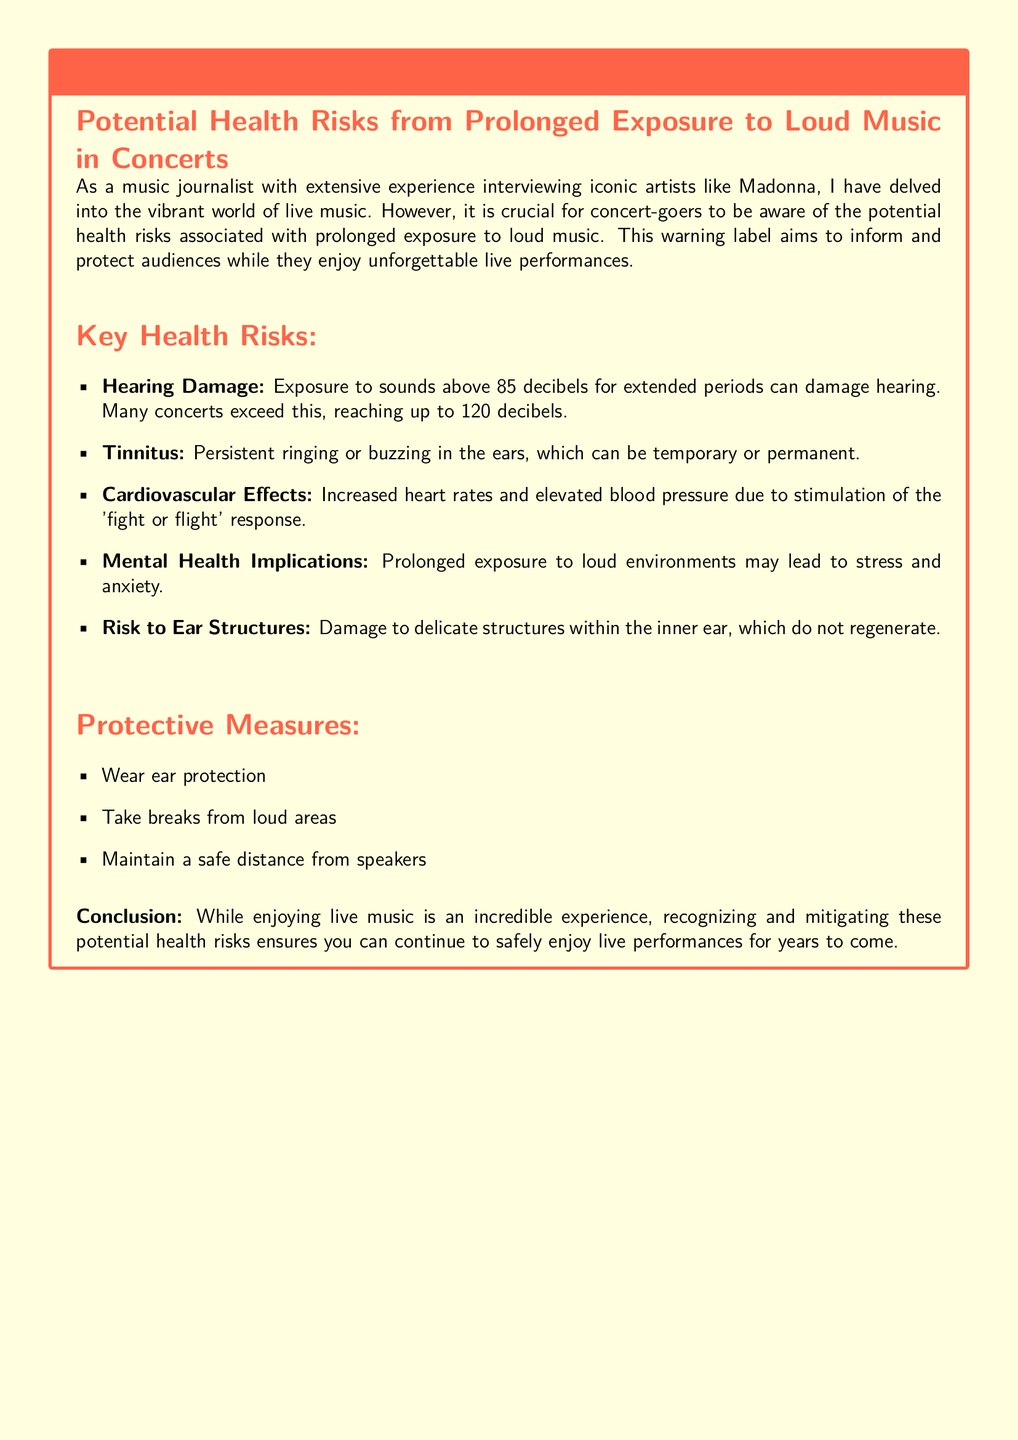What is the warning label about? The warning label informs concert-goers about potential health risks associated with prolonged exposure to loud music.
Answer: Potential Health Risks from Prolonged Exposure to Loud Music in Concerts What is the maximum decibel level mentioned? The document states that many concerts can reach up to 120 decibels, which can cause hearing damage.
Answer: 120 decibels What is a potential effect on hearing mentioned? One of the key health risks outlined is persistent ringing or buzzing in the ears, known as tinnitus.
Answer: Tinnitus What should concert-goers wear for protection? The document advises wearing ear protection to mitigate health risks associated with loud music.
Answer: Ear protection What cardiovascular effect does loud music have? The document notes that prolonged exposure to loud music may result in increased heart rates.
Answer: Increased heart rates What risk is associated with the inner ear? The document highlights the risk of damage to delicate structures within the inner ear that do not regenerate.
Answer: Damage to ear structures What is a recommended protective measure? The document suggests taking breaks from loud areas as a protective measure during concerts.
Answer: Take breaks from loud areas What mental health implication is noted? Prolonged exposure to loud environments may lead to stress and anxiety, as stated in the document.
Answer: Stress and anxiety How can concert-goers maintain safety? Maintaining a safe distance from speakers is one of the protective measures detailed in the label.
Answer: Maintain a safe distance from speakers 